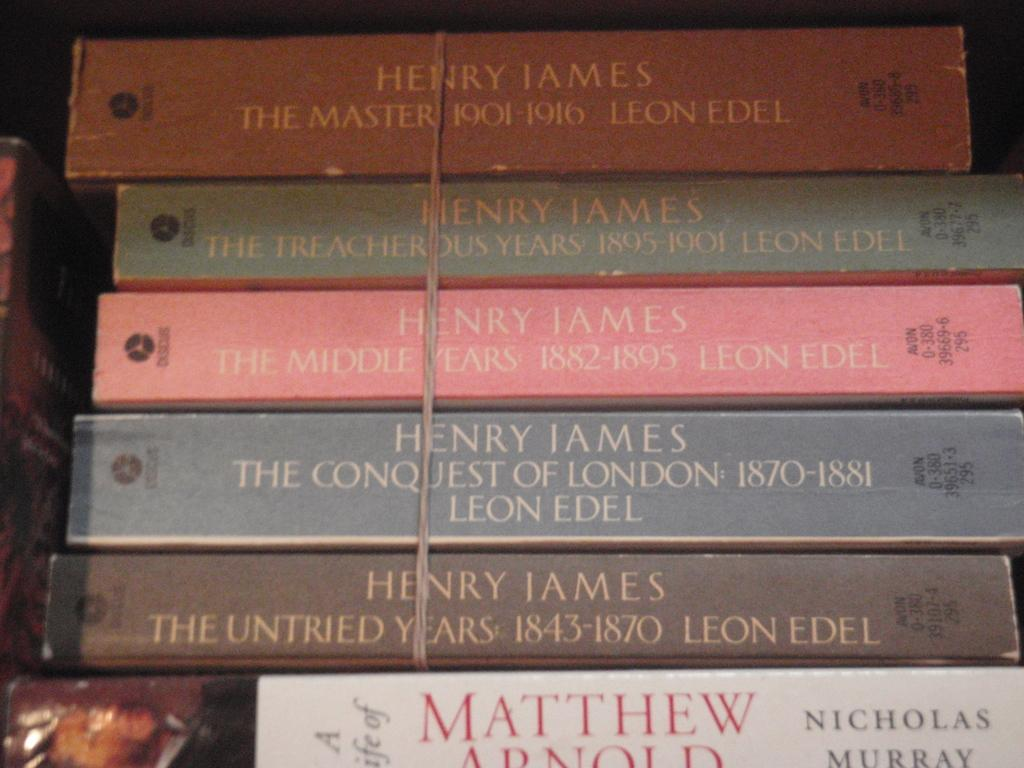What is the primary subject of the image? The primary subject of the image is many books. Can you describe the arrangement of the books in the image? There is a thread around five books in the image. What type of button can be seen attached to the books in the image? There is no button present in the image; it only shows a thread around five books. What kind of sticks are used to hold the books together in the image? There are no sticks present in the image; it only shows a thread around five books. 